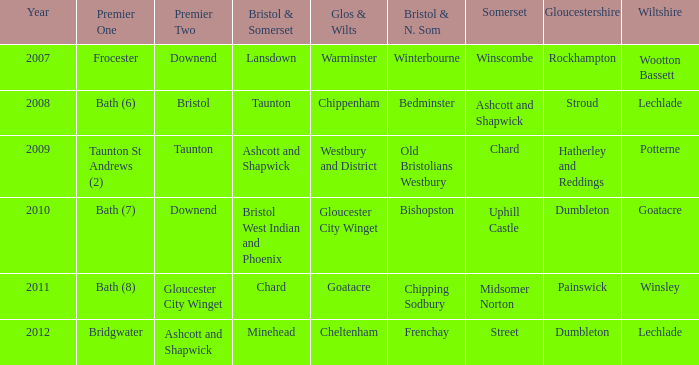Who many times is gloucestershire is painswick? 1.0. 